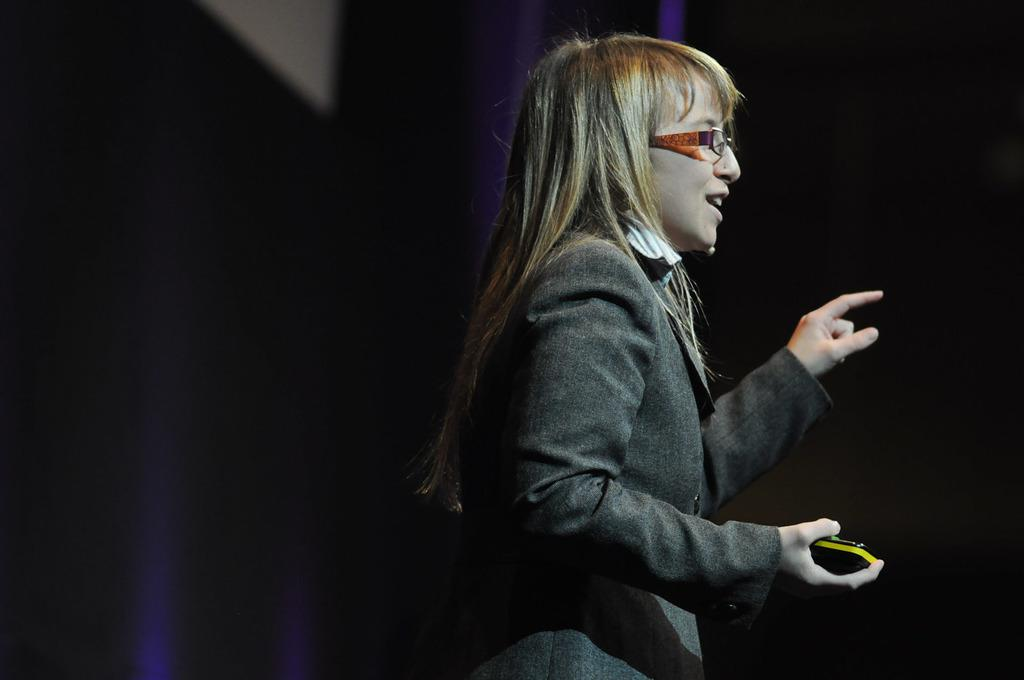Who is the main subject in the image? There is a woman in the image. What is the woman doing in the image? The woman is talking. What is the woman holding in her hand? The woman is holding an object in her hand. How is the background of the woman depicted in the image? The background of the woman is blurred. How many birds can be seen flying in the image? There are no birds visible in the image. What type of chairs are present in the image? There is no mention of chairs in the image. 